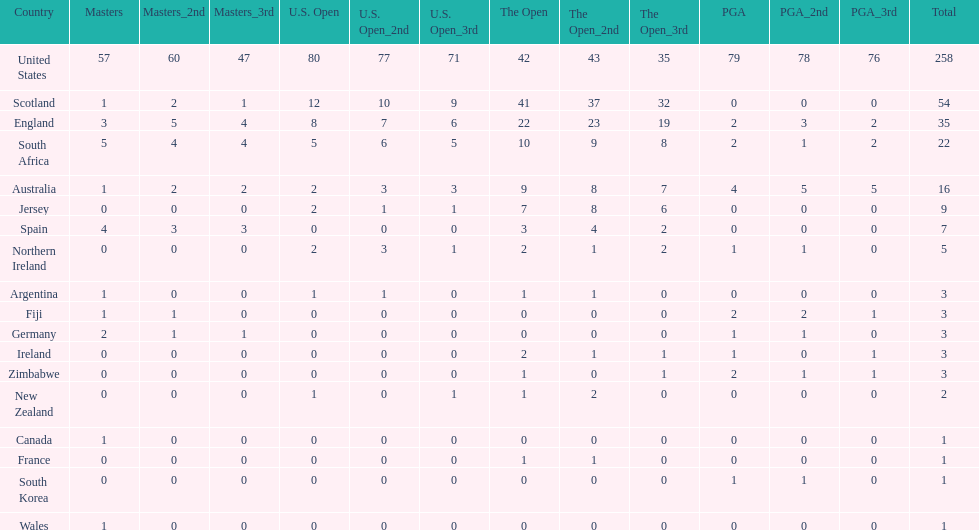How many countries have produced the same number of championship golfers as canada? 3. 